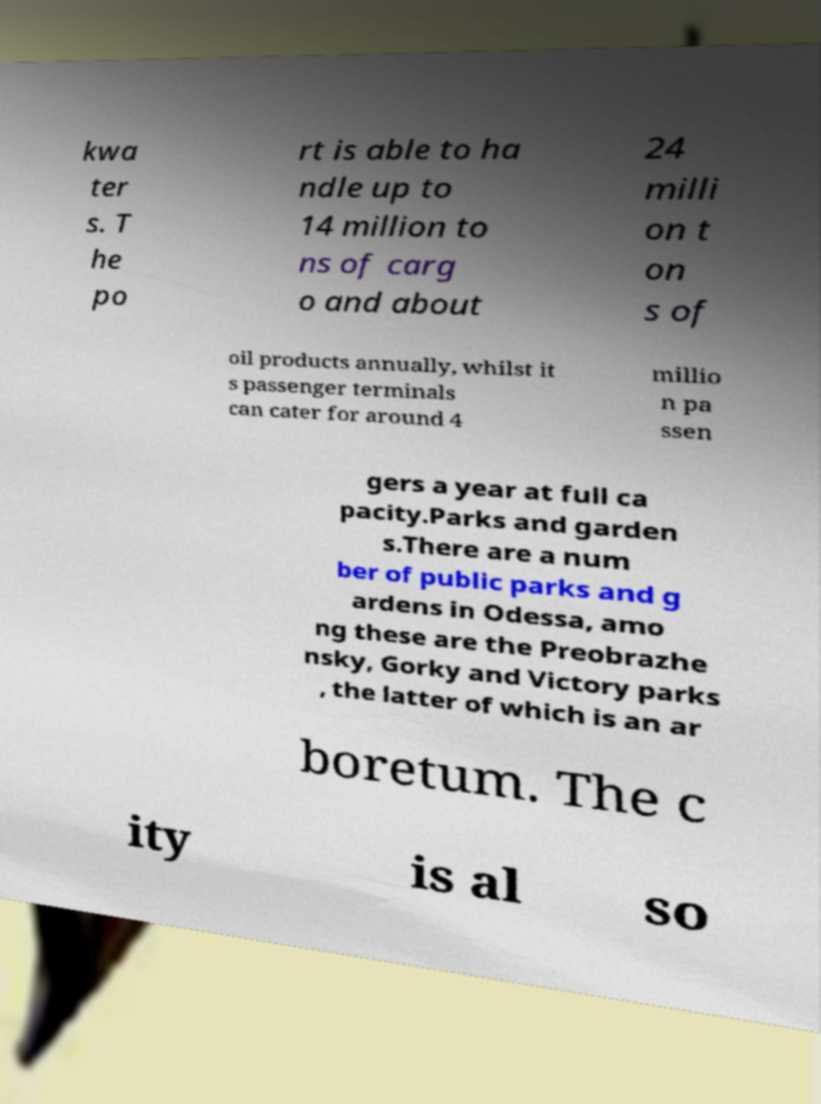There's text embedded in this image that I need extracted. Can you transcribe it verbatim? kwa ter s. T he po rt is able to ha ndle up to 14 million to ns of carg o and about 24 milli on t on s of oil products annually, whilst it s passenger terminals can cater for around 4 millio n pa ssen gers a year at full ca pacity.Parks and garden s.There are a num ber of public parks and g ardens in Odessa, amo ng these are the Preobrazhe nsky, Gorky and Victory parks , the latter of which is an ar boretum. The c ity is al so 